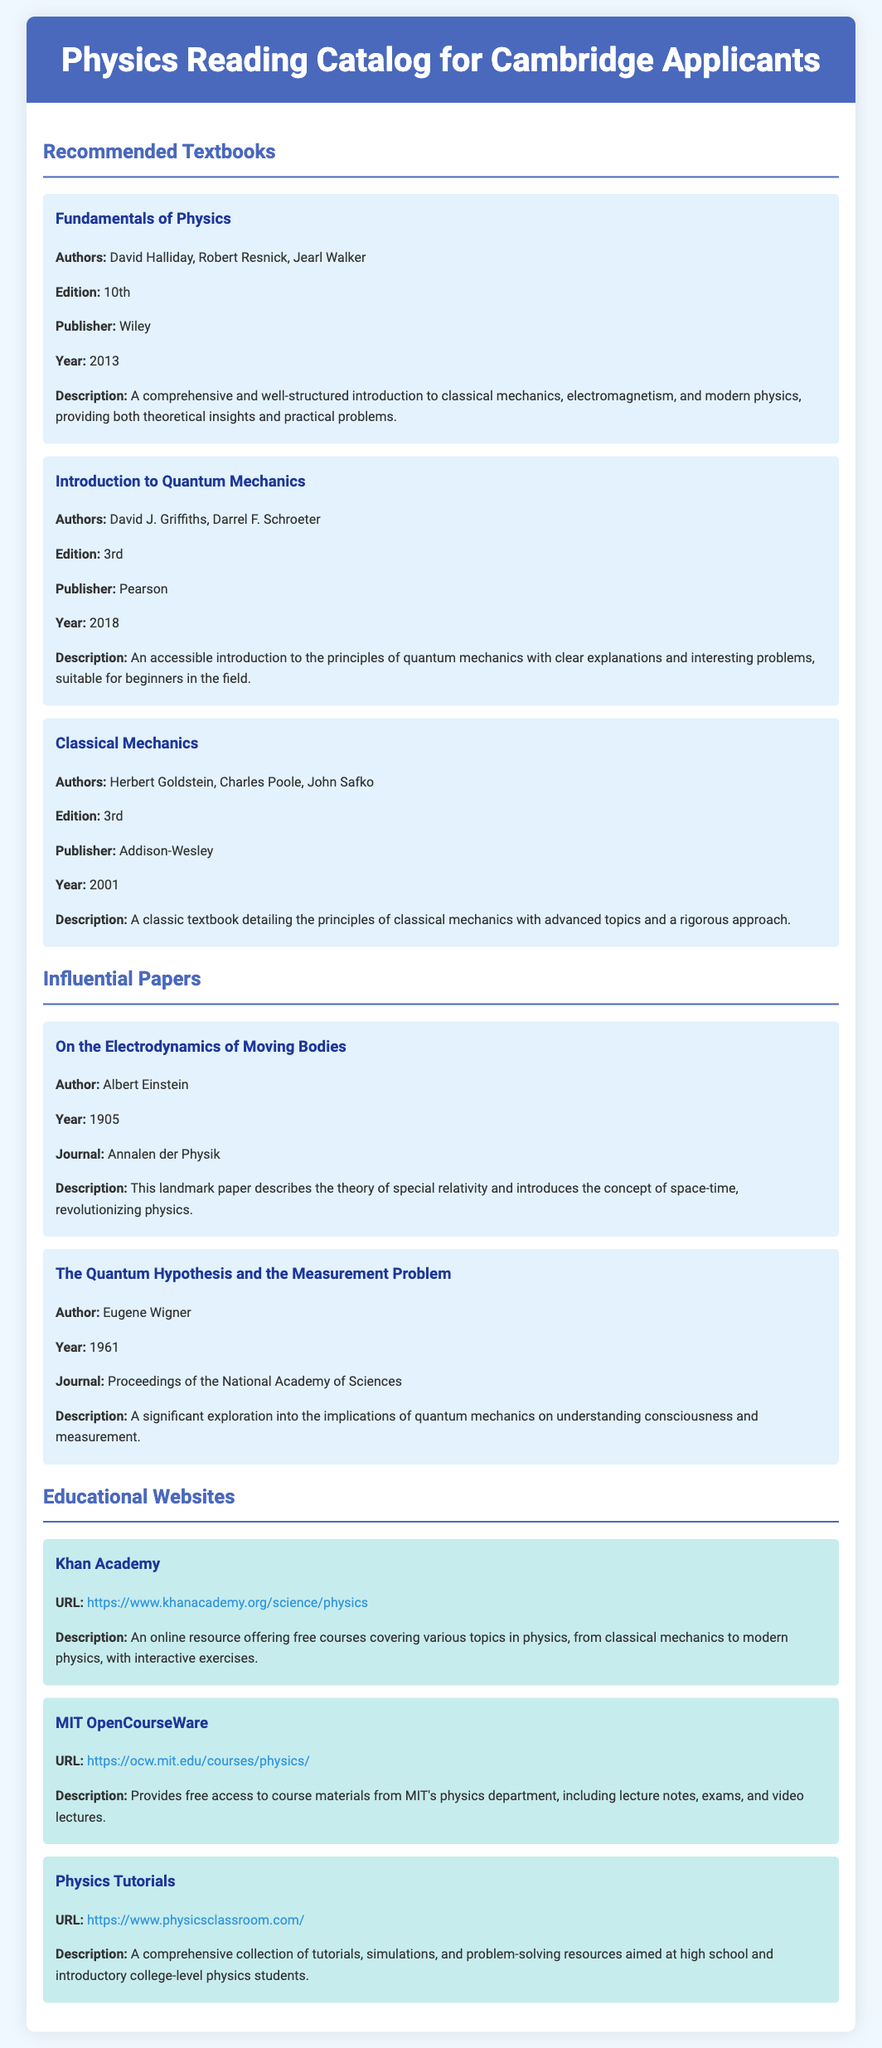What is the title of the first textbook listed? The title of the first textbook is found under the Recommended Textbooks section, and it is "Fundamentals of Physics."
Answer: Fundamentals of Physics Who are the authors of "Introduction to Quantum Mechanics"? The authors are mentioned in the description of the textbook, specifically in the Recommended Textbooks section.
Answer: David J. Griffiths, Darrel F. Schroeter What year was "On the Electrodynamics of Moving Bodies" published? The publication year is indicated in the Influential Papers section alongside the title.
Answer: 1905 How many educational websites are listed? The count can be determined by reviewing the Educational Websites section and counting the items.
Answer: 3 What is the URL for MIT OpenCourseWare? The URL is specifically mentioned in the Educational Websites section for that item.
Answer: https://ocw.mit.edu/courses/physics/ Which textbook edition was published in 2013? This information can be found by looking for the publication year in the Recommended Textbooks section.
Answer: 10th What is the primary subject of "Fundamentals of Physics"? The primary subject can be inferred from the described topics covered in the textbook in the document.
Answer: Classical mechanics, electromagnetism, and modern physics Who authored "The Quantum Hypothesis and the Measurement Problem"? The author's name is provided in the Influential Papers section next to the title of this paper.
Answer: Eugene Wigner 